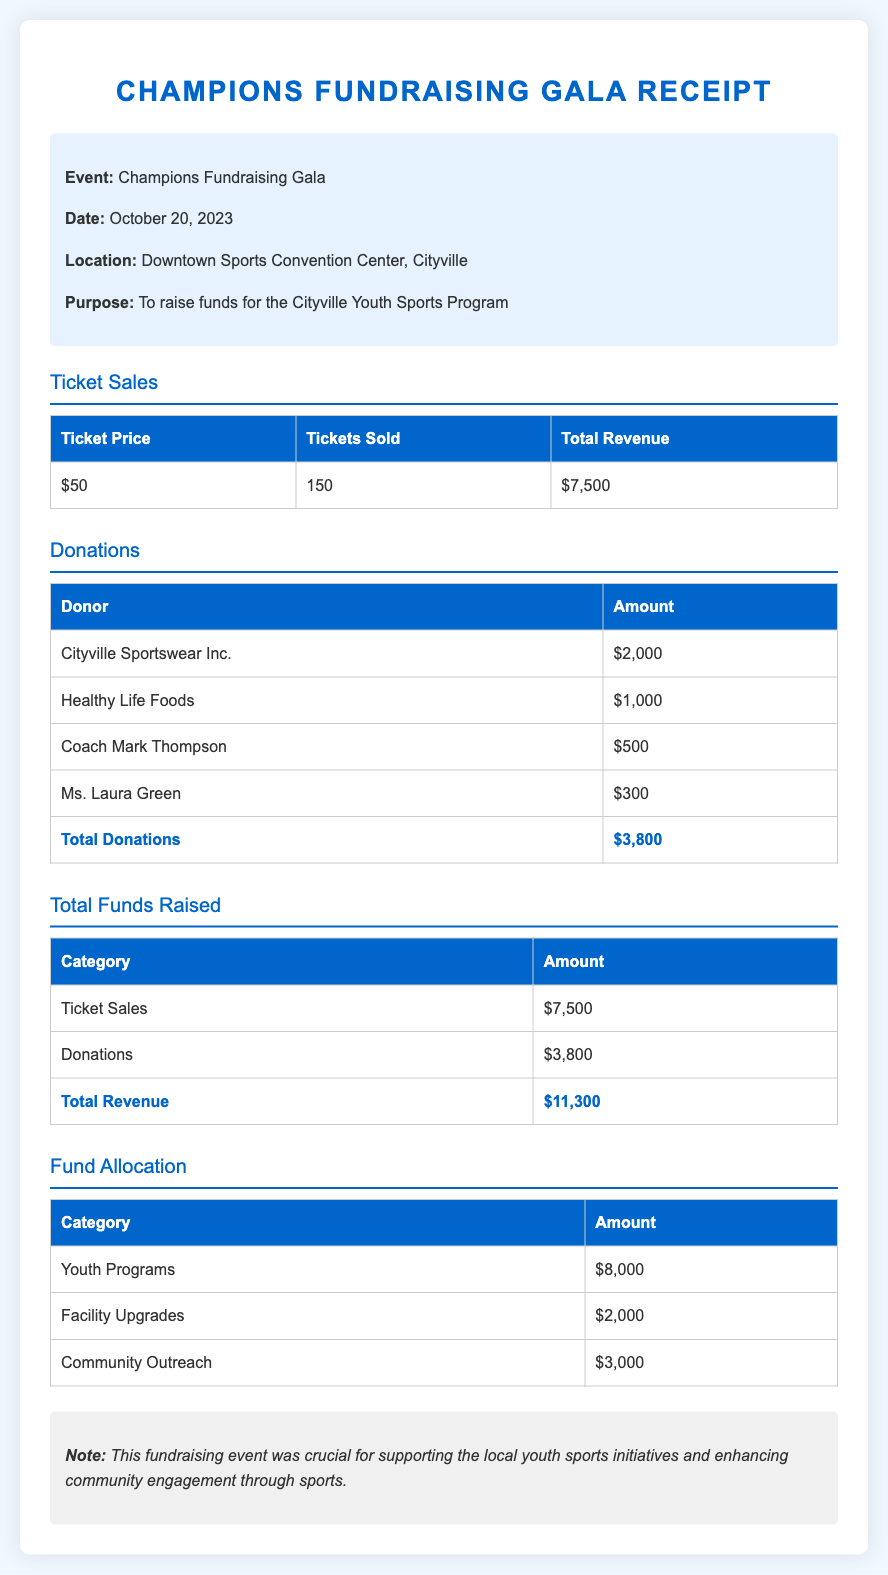What is the event name? The event is titled "Champions Fundraising Gala."
Answer: Champions Fundraising Gala What date was the event held? The document states the event date as October 20, 2023.
Answer: October 20, 2023 How much was the ticket price? The ticket price listed in the ticket sales section is $50.
Answer: $50 What was the total amount raised from ticket sales? The total revenue from ticket sales is provided in the document as $7,500.
Answer: $7,500 Who made the largest donation? The largest donation came from Cityville Sportswear Inc. for $2,000.
Answer: Cityville Sportswear Inc What is the total amount raised from donations? The total donations received are summed up to $3,800 in the donations section.
Answer: $3,800 What is the total funds raised from both ticket sales and donations? The total funds raised is calculated as $7,500 from ticket sales plus $3,800 from donations, equal to $11,300.
Answer: $11,300 How much is allocated for youth programs? The document specifically states that $8,000 is allocated for youth programs.
Answer: $8,000 What percentage of the total revenue is allocated to facility upgrades? The facility upgrades allocation is $2,000 out of a total revenue of $11,300, roughly 17.7%.
Answer: $2,000 What is the purpose of the fundraising event? The purpose is to raise funds for the Cityville Youth Sports Program.
Answer: To raise funds for the Cityville Youth Sports Program 